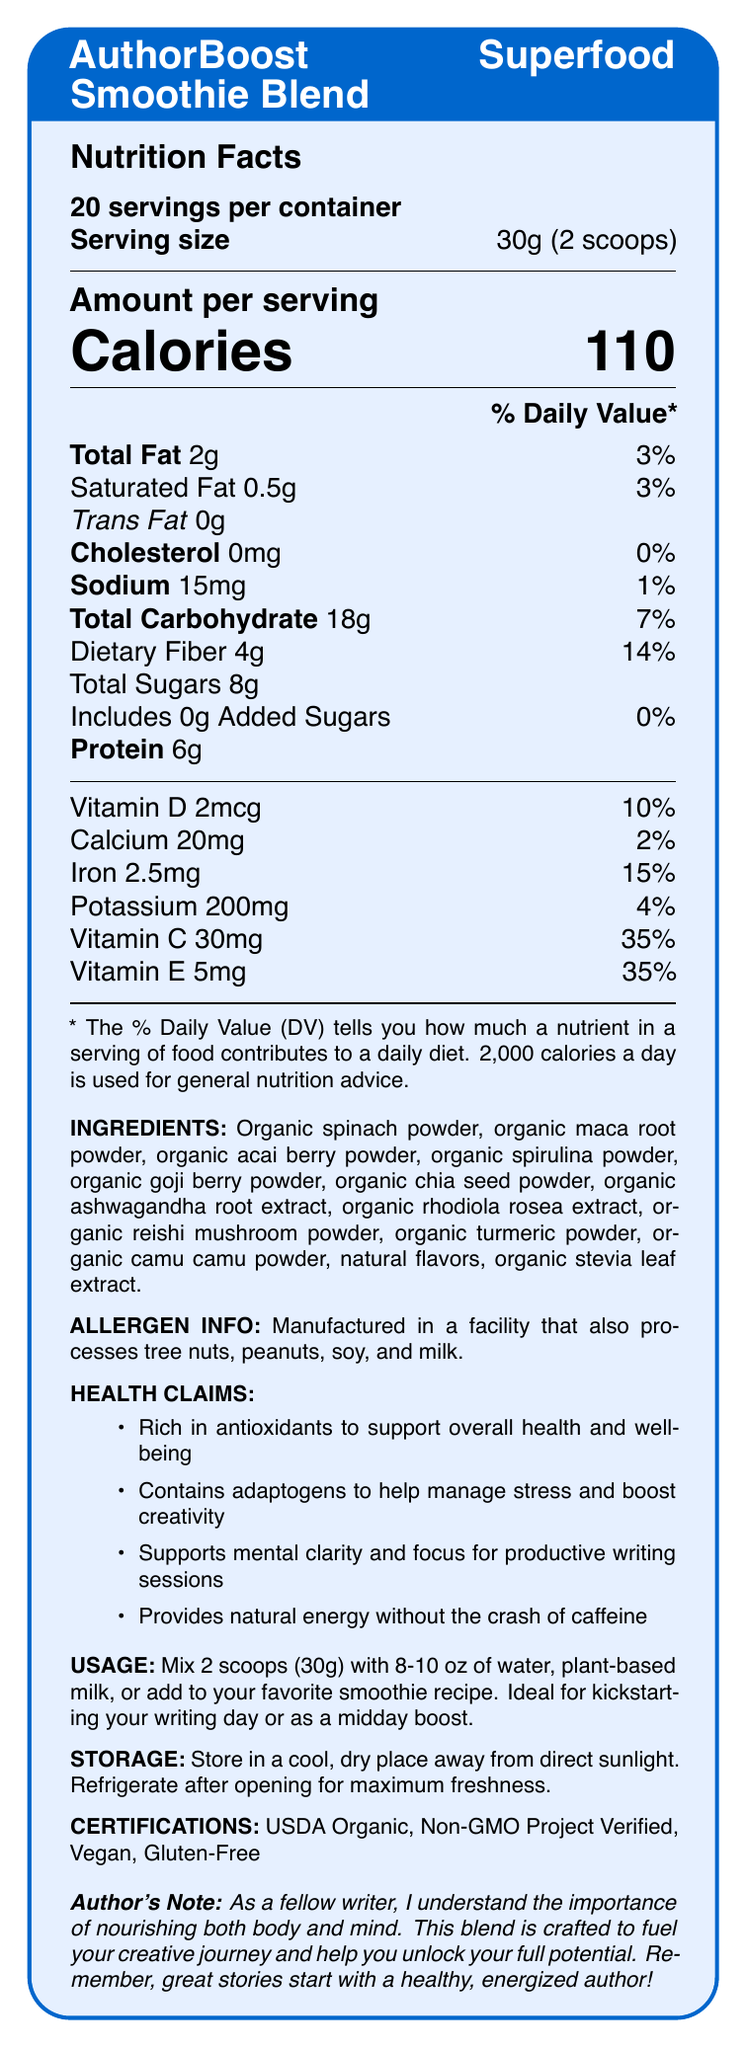what is the serving size of the AuthorBoost Superfood Smoothie Blend? The document specifically states the serving size as 30g (2 scoops).
Answer: 30g (2 scoops) how many calories are in one serving? The Nutrition Facts show that each serving contains 110 calories.
Answer: 110 what percentage of daily value of fibre does one serving provide? From the document, dietary fiber content per serving is 4g, which is 14% of the daily value.
Answer: 14% what are the main ingredients in the AuthorBoost Superfood Smoothie Blend? The document lists these ingredients under the "INGREDIENTS" section.
Answer: Organic spinach powder, Organic maca root powder, Organic acai berry powder, Organic spirulina powder, Organic goji berry powder, Organic chia seed powder, Organic ashwagandha root extract, Organic rhodiola rosea extract, Organic reishi mushroom powder, Organic turmeric powder, Organic camu camu powder, Natural flavors, Organic stevia leaf extract how much protein is there per serving? According to the Nutrition Facts, each serving contains 6g of protein.
Answer: 6g what is the recommended usage for the AuthorBoost Superfood Smoothie Blend? The recommended usage is mentioned in the "USAGE" section of the document.
Answer: Mix 2 scoops (30g) with 8-10 oz of water, plant-based milk, or add to a favorite smoothie recipe. which of the following is not a health claim of the AuthorBoost Superfood Smoothie Blend? 
A. Supports weight loss
B. Rich in antioxidants to support overall health and well-being
C. Contains adaptogens to help manage stress and boost creativity The document does not mention weight loss as a health claim for this product.
Answer: A how many vitamins are listed in the Nutrition Facts? 
A. Four 
B. Five 
C. Six 
D. Seven The Nutrition Facts list Vitamin D, Calcium, Iron, Potassium, Vitamin C, and Vitamin E, making it six vitamins.
Answer: C is the AuthorBoost Superfood Smoothie Blend gluten-free? The document indicates that one of the certifications is Gluten-Free.
Answer: Yes summarize the key information presented in the document The document outlines the nutritional details, certifications, health benefits, ingredients, and usage instructions for the superfood smoothie blend, targeting writers seeking mental clarity, energy, and overall health.
Answer: The document provides detailed nutrition facts for the AuthorBoost Superfood Smoothie Blend, such as serving size, calories, and daily values for various nutrients. It lists ingredients, allergen information, and health claims. The product is certified as USDA Organic, Non-GMO Project Verified, Vegan, and Gluten-Free. Instructions for usage and storage are included, along with an author's note emphasizing the importance of nutrition for writers. where is the product manufactured? The document does not provide information about the place of manufacture of the product.
Answer: Cannot be determined 